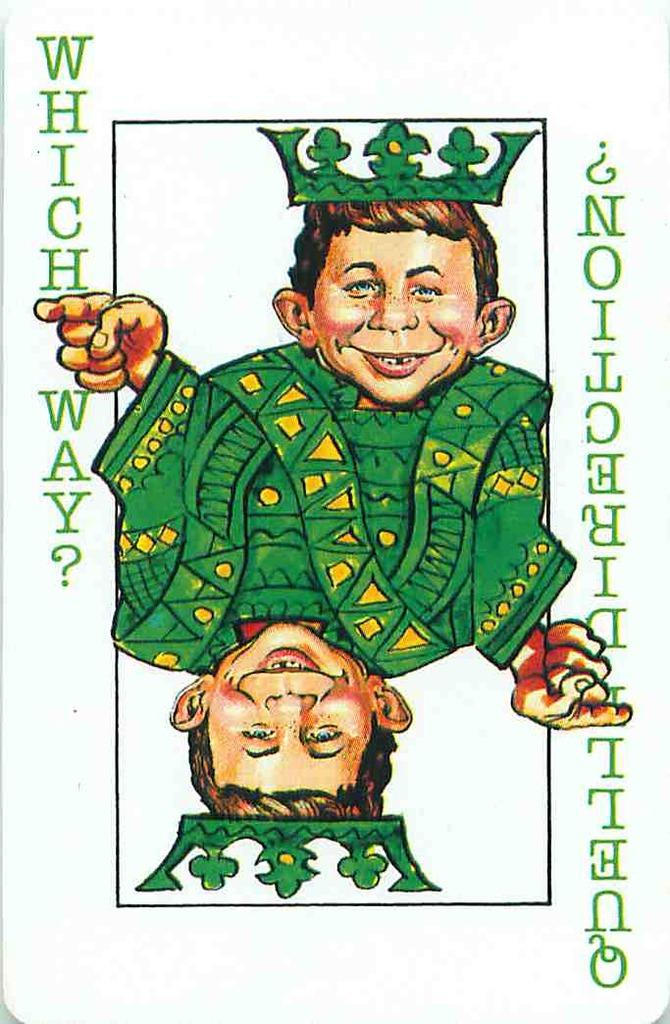What is the main object in the image? There is a card in the image. What is depicted on the card? The card has a print of a person. What is the person wearing? The person is wearing a green dress. Is there any text on the card? Yes, there is text written on the card. Can you tell me how many mint leaves are on the person's head in the image? There are no mint leaves present in the image; the person is wearing a green dress. What fact about the donkey can be observed in the image? There is no donkey present in the image. 